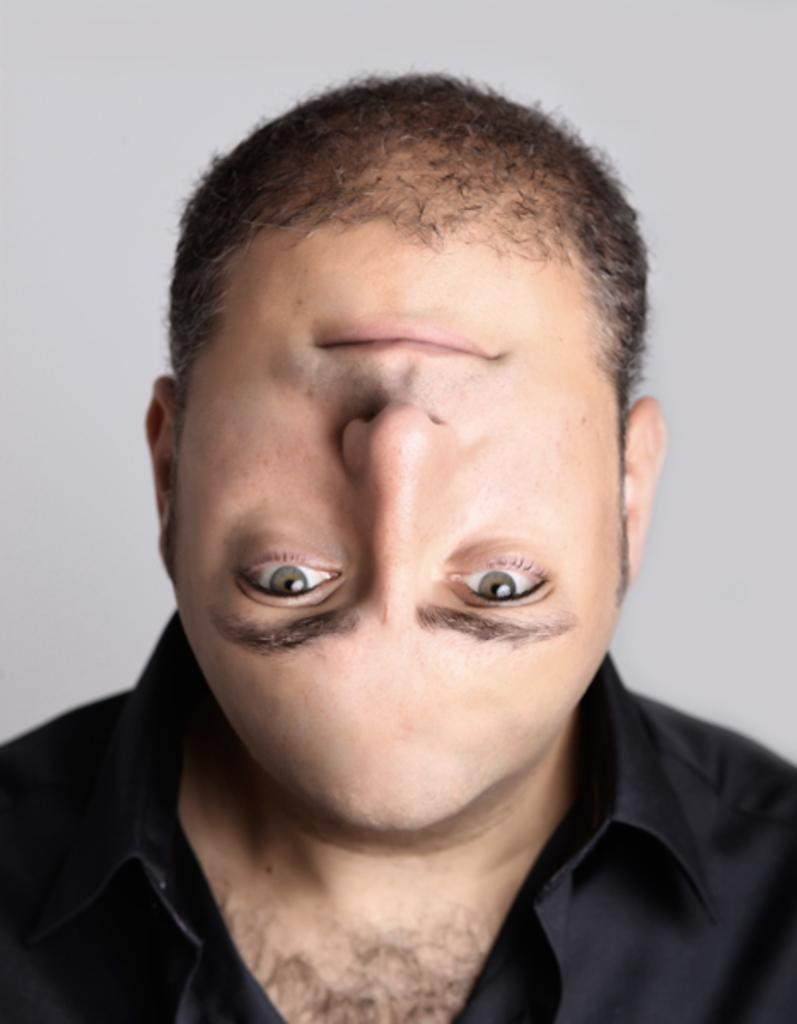What is the main subject of the image? There is a person in the image. What type of appliance is the person using to increase their profit in the image? There is no appliance or mention of profit in the image; it only features a person. 